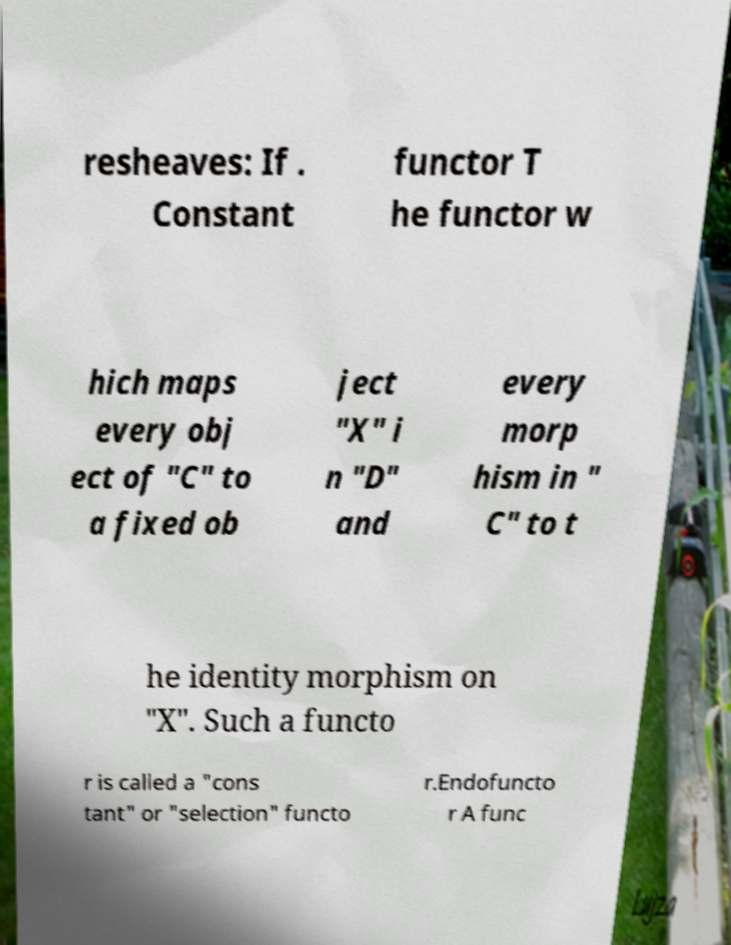Please read and relay the text visible in this image. What does it say? resheaves: If . Constant functor T he functor w hich maps every obj ect of "C" to a fixed ob ject "X" i n "D" and every morp hism in " C" to t he identity morphism on "X". Such a functo r is called a "cons tant" or "selection" functo r.Endofuncto r A func 